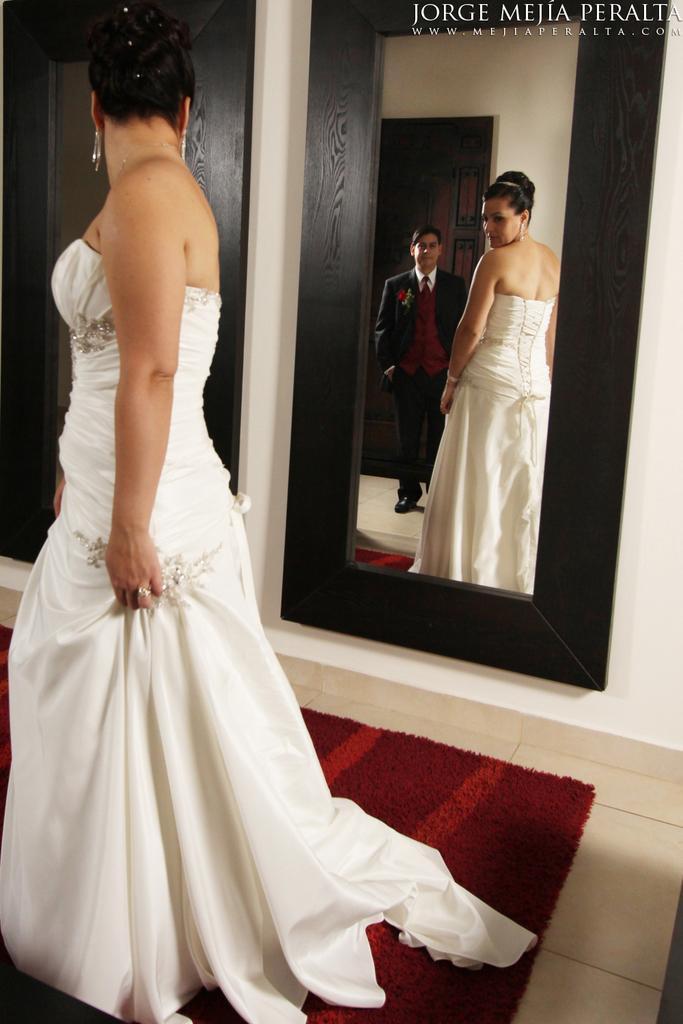Describe this image in one or two sentences. A woman is standing near to the mirror, a man is standing wearing suit, this is red color carpet. 